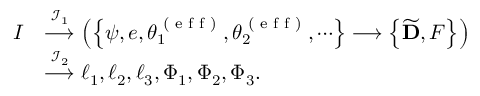Convert formula to latex. <formula><loc_0><loc_0><loc_500><loc_500>\begin{array} { r l } { I } & { \stackrel { { \mathcal { I } } _ { 1 } } { \longrightarrow } \left ( \left \{ \psi , e , \theta _ { 1 } ^ { ( e f f ) } , \theta _ { 2 } ^ { ( e f f ) } , \cdots \right \} \longrightarrow \left \{ \widetilde { D } , F \right \} \right ) } \\ & { \stackrel { { \mathcal { I } } _ { 2 } } { \longrightarrow } \ell _ { 1 } , \ell _ { 2 } , \ell _ { 3 } , \Phi _ { 1 } , \Phi _ { 2 } , \Phi _ { 3 } . } \end{array}</formula> 